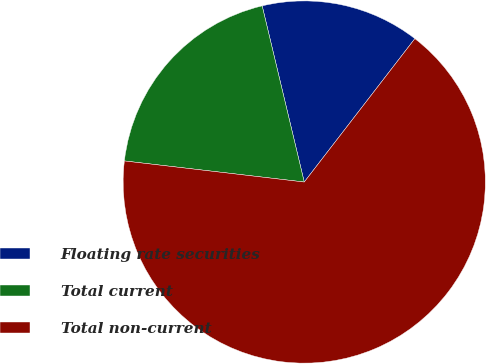Convert chart. <chart><loc_0><loc_0><loc_500><loc_500><pie_chart><fcel>Floating rate securities<fcel>Total current<fcel>Total non-current<nl><fcel>14.19%<fcel>19.41%<fcel>66.4%<nl></chart> 